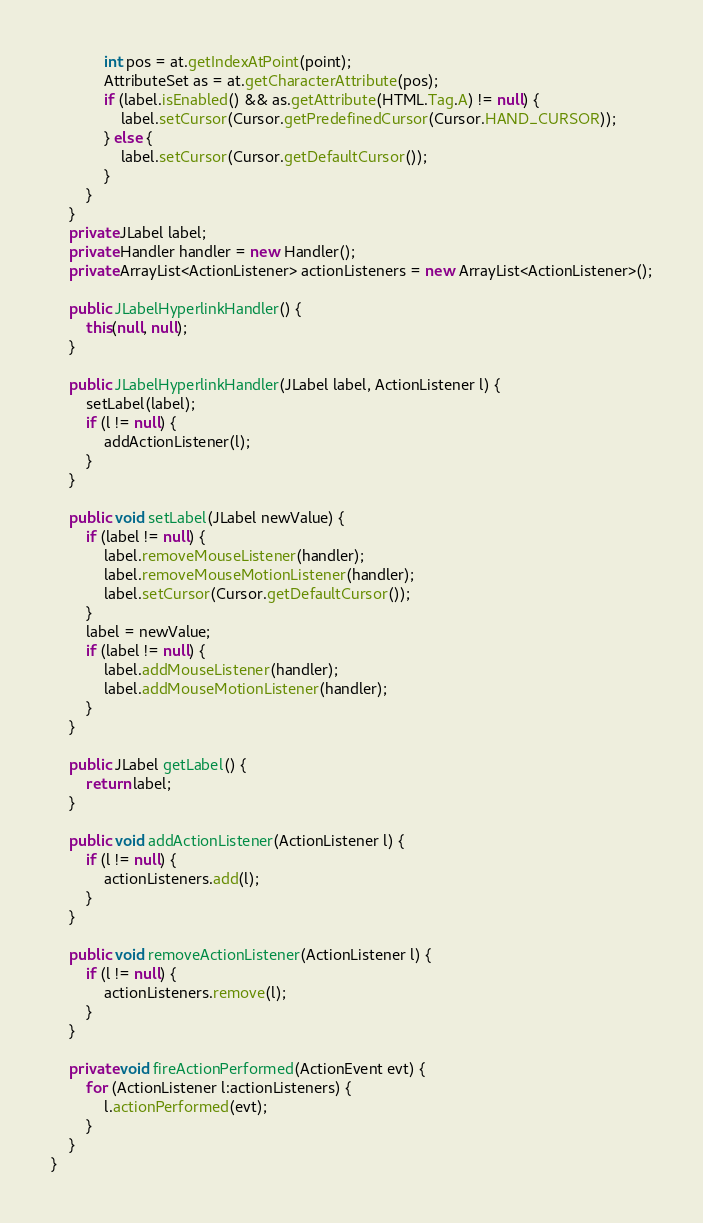<code> <loc_0><loc_0><loc_500><loc_500><_Java_>            int pos = at.getIndexAtPoint(point);
            AttributeSet as = at.getCharacterAttribute(pos);
            if (label.isEnabled() && as.getAttribute(HTML.Tag.A) != null) {
                label.setCursor(Cursor.getPredefinedCursor(Cursor.HAND_CURSOR));
            } else {
                label.setCursor(Cursor.getDefaultCursor());
            }
        }
    }
    private JLabel label;
    private Handler handler = new Handler();
    private ArrayList<ActionListener> actionListeners = new ArrayList<ActionListener>();

    public JLabelHyperlinkHandler() {
        this(null, null);
    }

    public JLabelHyperlinkHandler(JLabel label, ActionListener l) {
        setLabel(label);
        if (l != null) {
            addActionListener(l);
        }
    }

    public void setLabel(JLabel newValue) {
        if (label != null) {
            label.removeMouseListener(handler);
            label.removeMouseMotionListener(handler);
            label.setCursor(Cursor.getDefaultCursor());
        }
        label = newValue;
        if (label != null) {
            label.addMouseListener(handler);
            label.addMouseMotionListener(handler);
        }
    }

    public JLabel getLabel() {
        return label;
    }

    public void addActionListener(ActionListener l) {
        if (l != null) {
            actionListeners.add(l);
        }
    }

    public void removeActionListener(ActionListener l) {
        if (l != null) {
            actionListeners.remove(l);
        }
    }
    
    private void fireActionPerformed(ActionEvent evt) {
        for (ActionListener l:actionListeners) {
            l.actionPerformed(evt);
        }
    }
}
</code> 